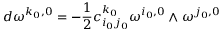<formula> <loc_0><loc_0><loc_500><loc_500>d \omega ^ { k _ { 0 } , 0 } = - \frac { 1 } { 2 } c _ { i _ { 0 } j _ { 0 } } ^ { k _ { 0 } } \omega ^ { i _ { 0 } , 0 } \wedge \omega ^ { j _ { 0 } , 0 }</formula> 